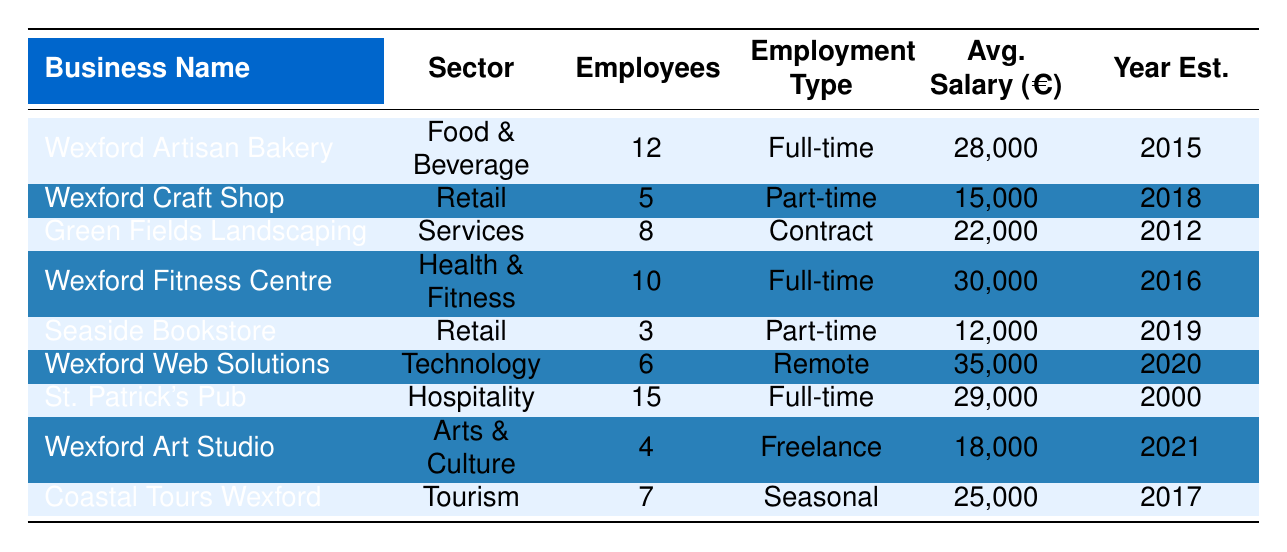What's the highest average salary among the businesses listed? The table shows the average salaries for each business. The highest salary is €35,000 from Wexford Web Solutions.
Answer: €35,000 How many full-time employees are there in total? There are three businesses with full-time employees: Wexford Artisan Bakery (12), Wexford Fitness Centre (10), and St. Patrick's Pub (15). Adding these amounts gives 12 + 10 + 15 = 37.
Answer: 37 Which business was established most recently? The table lists the year established for each business. The most recent year is 2021, and Wexford Art Studio was established in that year.
Answer: Wexford Art Studio Is there a business in the retail sector with more than 5 employees? The table states that the Wexford Craft Shop has 5 employees, and Seaside Bookstore has 3. Thus, no retail business has more than 5 employees.
Answer: No What is the average salary of all businesses listed in the table? To find the average salary, first, we sum the average salaries: 28,000 + 15,000 + 22,000 + 30,000 + 12,000 + 35,000 + 29,000 + 18,000 + 25,000 =  204,000. Then divide by the number of businesses (9), resulting in 204,000 / 9 = 22,666.67.
Answer: €22,666.67 How many businesses are located in Wexford town? From the table, four businesses are based in Wexford town: Wexford Artisan Bakery, Wexford Fitness Centre, Wexford Web Solutions, and St. Patrick's Pub.
Answer: 4 Which two businesses have the largest employee count? The two businesses with the largest employee counts are St. Patrick's Pub (15 employees) and Wexford Artisan Bakery (12 employees).
Answer: St. Patrick's Pub and Wexford Artisan Bakery What percentage of businesses employ contract workers? Out of the 9 listed businesses, only one (Green Fields Landscaping) employs contract workers. The percentage is (1/9) * 100 = 11.11%.
Answer: 11.11% Is there a business in the tourism sector? Yes, the Coastal Tours Wexford operates in the tourism sector, as indicated in the table.
Answer: Yes What is the median average salary among the businesses in this table? First, we gather the average salaries: 12,000; 15,000; 18,000; 22,000; 25,000; 28,000; 29,000; 30,000; 35,000. Sorting them gives us: 12,000; 15,000; 18,000; 22,000; 25,000; 28,000; 29,000; 30,000; 35,000. The median is the middle value, which for 9 businesses is 25,000.
Answer: €25,000 